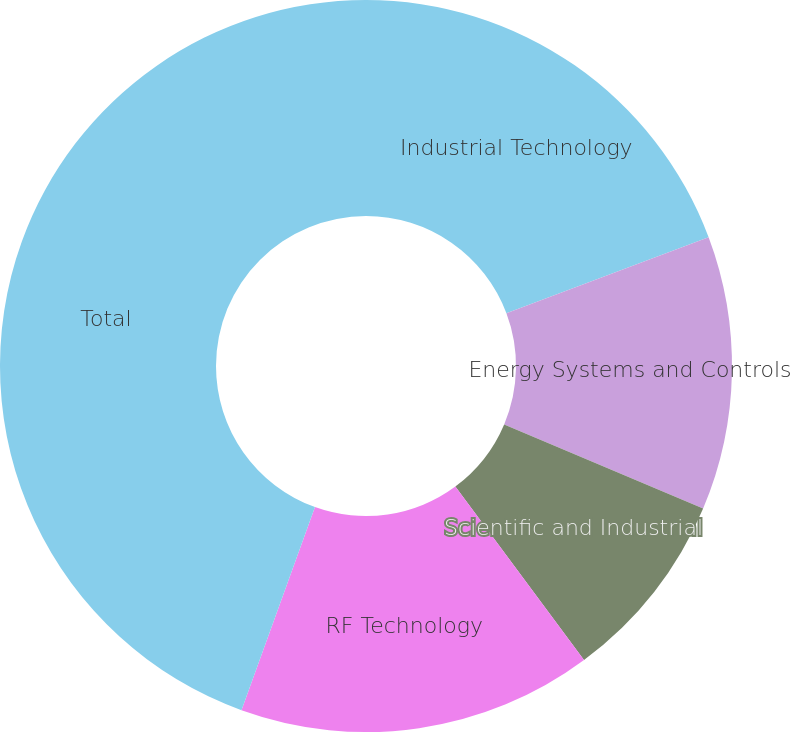Convert chart. <chart><loc_0><loc_0><loc_500><loc_500><pie_chart><fcel>Industrial Technology<fcel>Energy Systems and Controls<fcel>Scientific and Industrial<fcel>RF Technology<fcel>Total<nl><fcel>19.28%<fcel>12.08%<fcel>8.48%<fcel>15.68%<fcel>44.47%<nl></chart> 